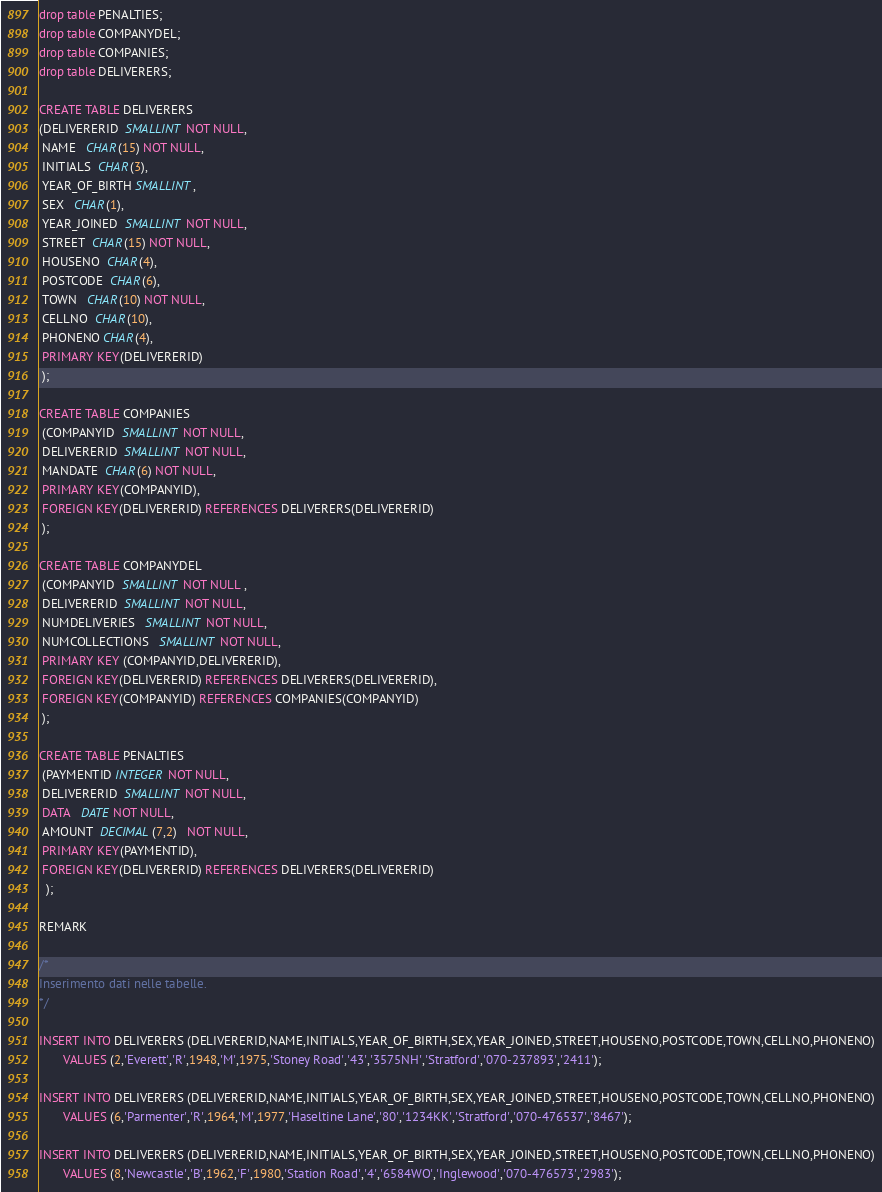Convert code to text. <code><loc_0><loc_0><loc_500><loc_500><_SQL_>drop table PENALTIES;
drop table COMPANYDEL;
drop table COMPANIES;
drop table DELIVERERS;

CREATE TABLE DELIVERERS
(DELIVERERID  SMALLINT NOT NULL,
 NAME   CHAR(15) NOT NULL,
 INITIALS  CHAR(3),
 YEAR_OF_BIRTH SMALLINT,
 SEX   CHAR(1),
 YEAR_JOINED  SMALLINT NOT NULL,
 STREET  CHAR(15) NOT NULL,
 HOUSENO  CHAR(4),
 POSTCODE  CHAR(6),
 TOWN   CHAR(10) NOT NULL,
 CELLNO  CHAR(10),
 PHONENO CHAR(4),
 PRIMARY KEY(DELIVERERID)
 );

CREATE TABLE COMPANIES
 (COMPANYID  SMALLINT NOT NULL,
 DELIVERERID  SMALLINT NOT NULL,
 MANDATE  CHAR(6) NOT NULL,
 PRIMARY KEY(COMPANYID),
 FOREIGN KEY(DELIVERERID) REFERENCES DELIVERERS(DELIVERERID)
 );

CREATE TABLE COMPANYDEL
 (COMPANYID  SMALLINT NOT NULL ,
 DELIVERERID  SMALLINT NOT NULL,
 NUMDELIVERIES   SMALLINT NOT NULL,
 NUMCOLLECTIONS   SMALLINT NOT NULL,
 PRIMARY KEY (COMPANYID,DELIVERERID),
 FOREIGN KEY(DELIVERERID) REFERENCES DELIVERERS(DELIVERERID),
 FOREIGN KEY(COMPANYID) REFERENCES COMPANIES(COMPANYID)
 );

CREATE TABLE PENALTIES
 (PAYMENTID INTEGER NOT NULL,
 DELIVERERID  SMALLINT NOT NULL,
 DATA   DATE NOT NULL,
 AMOUNT  DECIMAL(7,2)   NOT NULL,
 PRIMARY KEY(PAYMENTID),
 FOREIGN KEY(DELIVERERID) REFERENCES DELIVERERS(DELIVERERID)
  );

REMARK

/*
Inserimento dati nelle tabelle.
*/

INSERT INTO DELIVERERS (DELIVERERID,NAME,INITIALS,YEAR_OF_BIRTH,SEX,YEAR_JOINED,STREET,HOUSENO,POSTCODE,TOWN,CELLNO,PHONENO)
       VALUES (2,'Everett','R',1948,'M',1975,'Stoney Road','43','3575NH','Stratford','070-237893','2411');

INSERT INTO DELIVERERS (DELIVERERID,NAME,INITIALS,YEAR_OF_BIRTH,SEX,YEAR_JOINED,STREET,HOUSENO,POSTCODE,TOWN,CELLNO,PHONENO)
       VALUES (6,'Parmenter','R',1964,'M',1977,'Haseltine Lane','80','1234KK','Stratford','070-476537','8467');

INSERT INTO DELIVERERS (DELIVERERID,NAME,INITIALS,YEAR_OF_BIRTH,SEX,YEAR_JOINED,STREET,HOUSENO,POSTCODE,TOWN,CELLNO,PHONENO)
       VALUES (8,'Newcastle','B',1962,'F',1980,'Station Road','4','6584WO','Inglewood','070-476573','2983');
</code> 